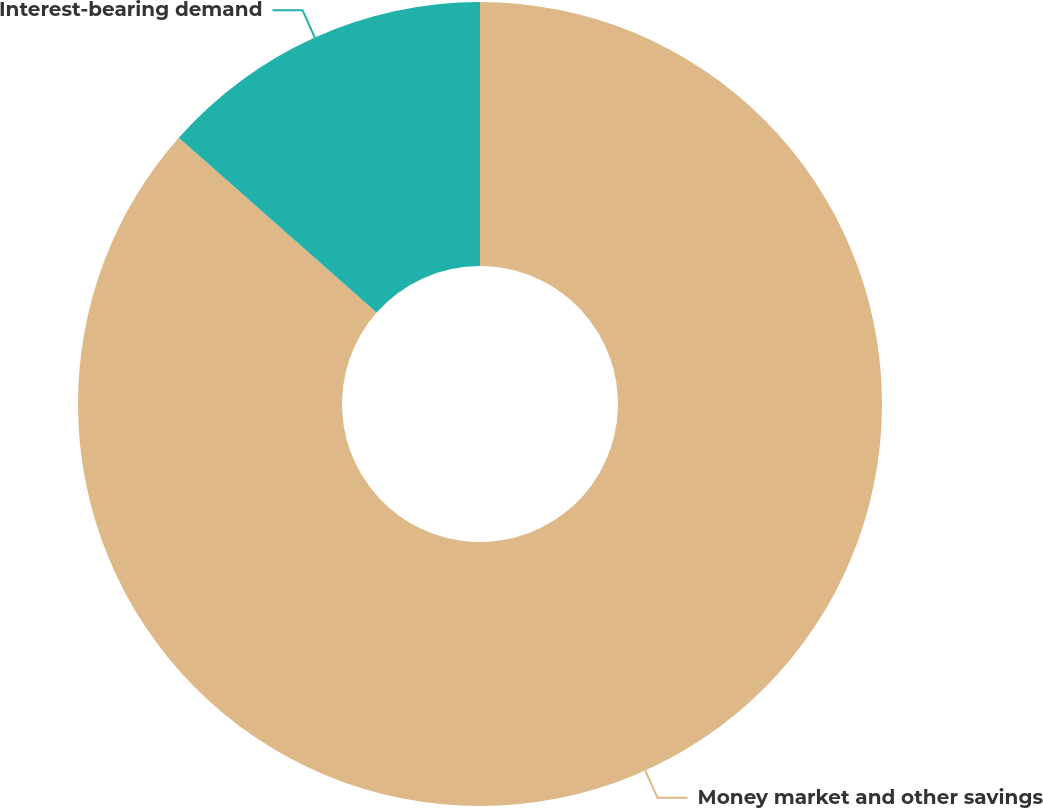Convert chart to OTSL. <chart><loc_0><loc_0><loc_500><loc_500><pie_chart><fcel>Money market and other savings<fcel>Interest-bearing demand<nl><fcel>86.52%<fcel>13.48%<nl></chart> 